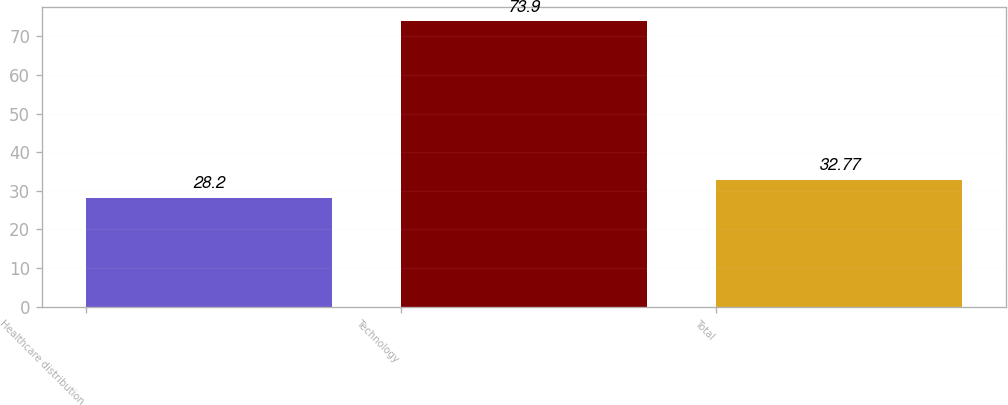<chart> <loc_0><loc_0><loc_500><loc_500><bar_chart><fcel>Healthcare distribution<fcel>Technology<fcel>Total<nl><fcel>28.2<fcel>73.9<fcel>32.77<nl></chart> 